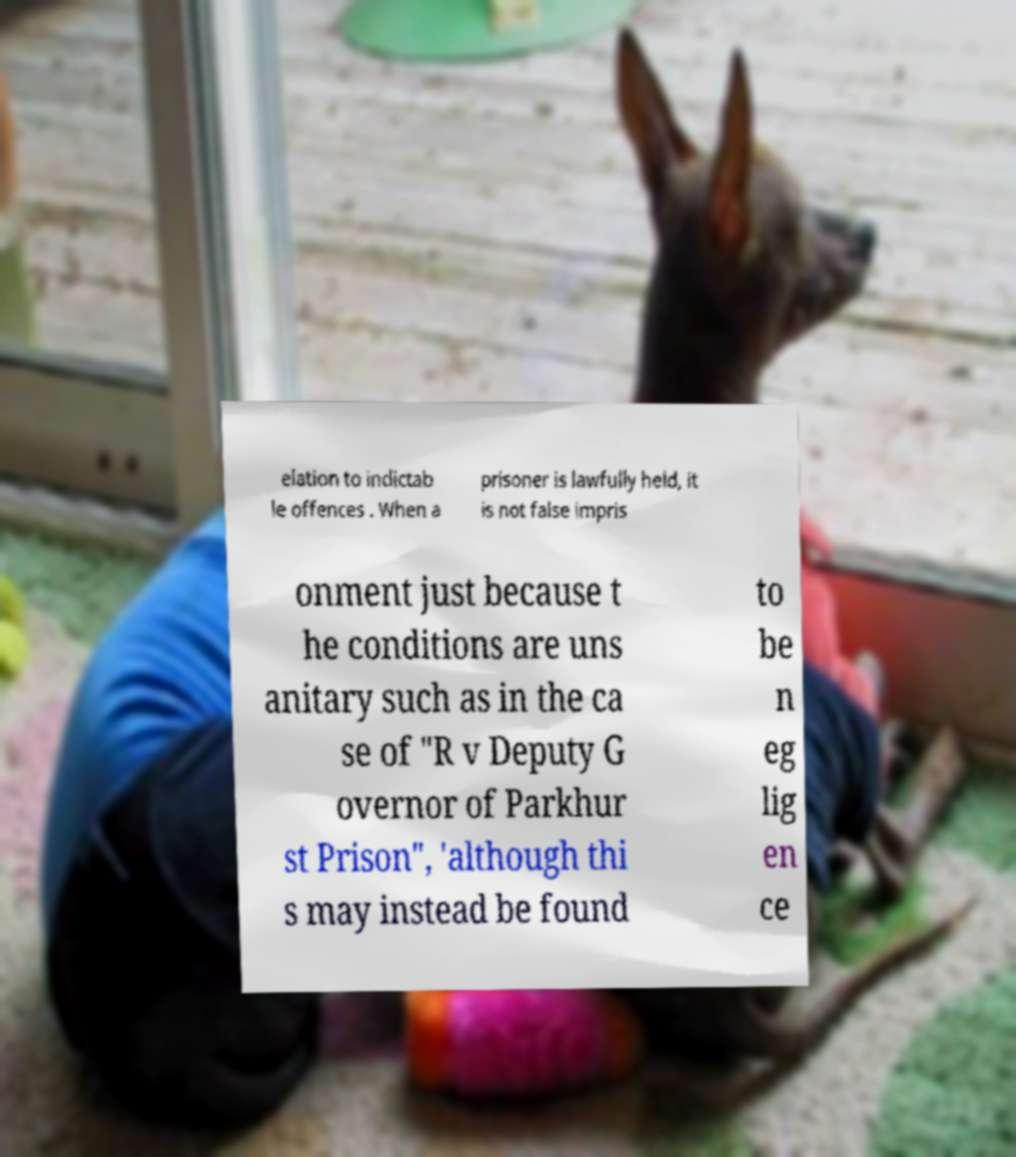For documentation purposes, I need the text within this image transcribed. Could you provide that? elation to indictab le offences . When a prisoner is lawfully held, it is not false impris onment just because t he conditions are uns anitary such as in the ca se of "R v Deputy G overnor of Parkhur st Prison", 'although thi s may instead be found to be n eg lig en ce 